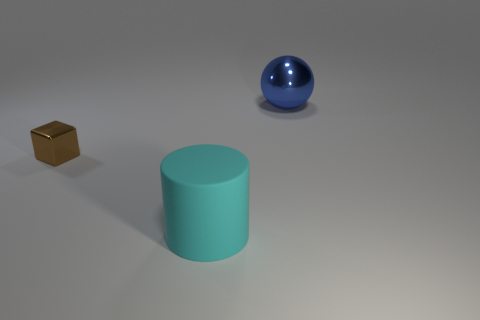What does the arrangement of these objects suggest about their purpose? The objects are spaced apart on a neutral background, which suggests they might be subject to some form of comparison or scrutiny, perhaps for a study of geometry, material properties, or light reflection. Their deliberate placement could also imply an exercise in digital rendering techniques, showcasing texture, shading, and lighting effects within a three-dimensional modeling environment. 